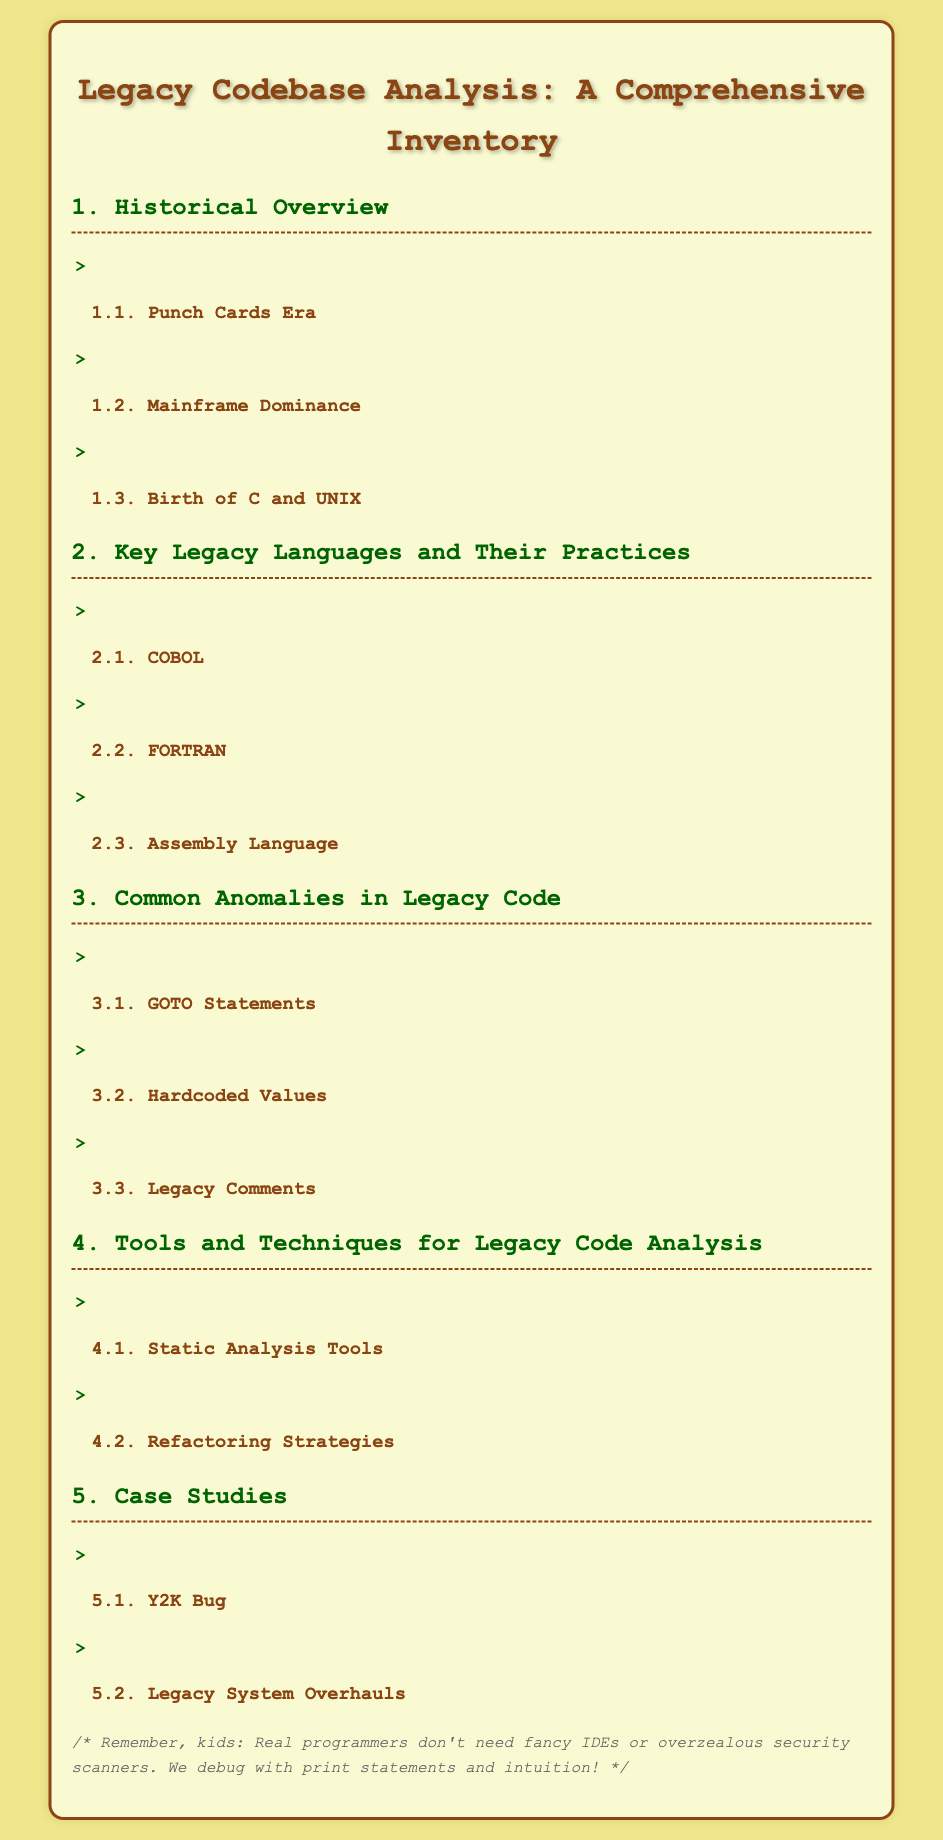What is the title of the document? The title of the document is clearly stated at the top of the rendered content.
Answer: Legacy Codebase Analysis: A Comprehensive Inventory How many sections are in the document? The document consists of five main sections as indicated by the numbered headings.
Answer: 5 What is the first historical era mentioned? The document lists specific historical eras in section 1, with the first being highlighted in subsection 1.1.
Answer: Punch Cards Era Name one of the legacy languages discussed. Section 2 lists key legacy languages, and one is provided as a subsection.
Answer: COBOL What is one common anomaly in legacy code? Section 3 mentions specific issues related to legacy code, with several listed as subsections.
Answer: GOTO Statements Which case study addresses a significant bug? Section 5 discusses specific case studies, one of which pertains to a well-known computer issue.
Answer: Y2K Bug What type of analysis tools are mentioned? Section 4 outlines tools used for analyzing legacy code, including specific types in subsections.
Answer: Static Analysis Tools What is the background color of the document? The background color is specified in the style section, defining the visual theme of the page.
Answer: #F0E68C 